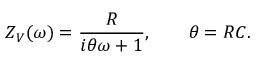<formula> <loc_0><loc_0><loc_500><loc_500>Z _ { V } ( \omega ) = \frac { R } { i \theta \omega + 1 } , \quad \theta = R C .</formula> 